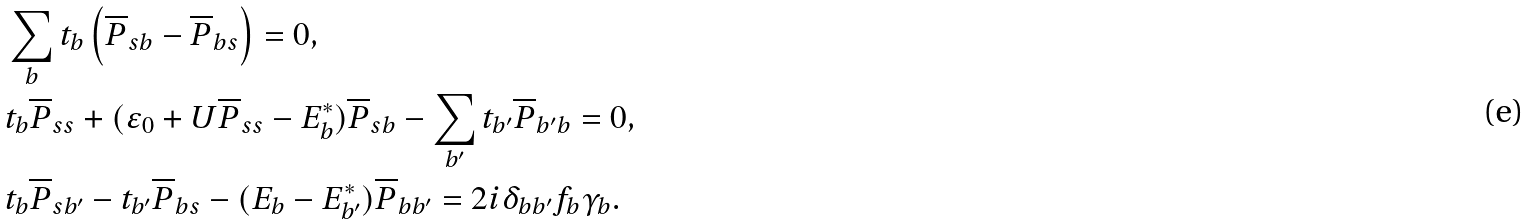Convert formula to latex. <formula><loc_0><loc_0><loc_500><loc_500>& \sum _ { b } t _ { b } \left ( \overline { P } _ { s b } - \overline { P } _ { b s } \right ) = 0 , \\ & t _ { b } \overline { P } _ { s s } + ( \varepsilon _ { 0 } + U \overline { P } _ { s s } - E ^ { * } _ { b } ) \overline { P } _ { s b } - \sum _ { b ^ { \prime } } t _ { b ^ { \prime } } \overline { P } _ { b ^ { \prime } b } = 0 , \\ & t _ { b } \overline { P } _ { s b ^ { \prime } } - t _ { b ^ { \prime } } \overline { P } _ { b s } - ( E _ { b } - E ^ { * } _ { b ^ { \prime } } ) \overline { P } _ { b b ^ { \prime } } = 2 i \delta _ { b b ^ { \prime } } f _ { b } \gamma _ { b } .</formula> 